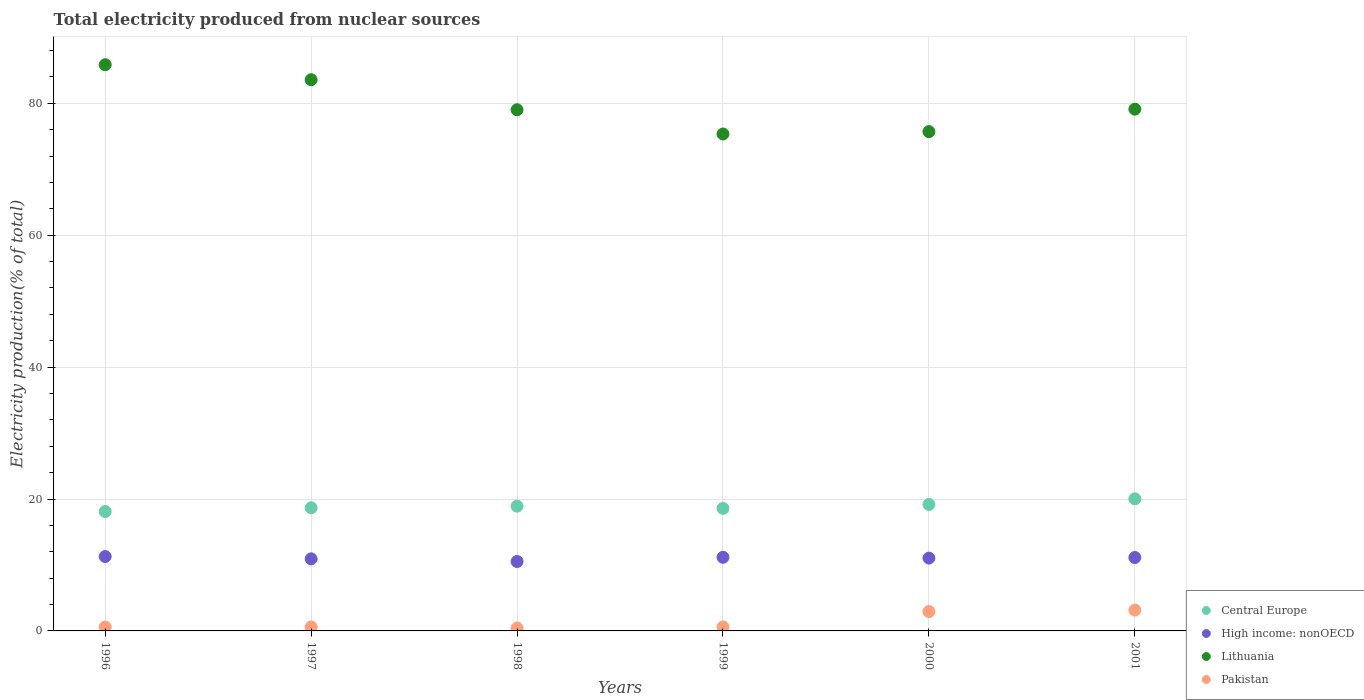How many different coloured dotlines are there?
Ensure brevity in your answer.  4. Is the number of dotlines equal to the number of legend labels?
Give a very brief answer. Yes. What is the total electricity produced in Lithuania in 1999?
Offer a very short reply. 75.35. Across all years, what is the maximum total electricity produced in Pakistan?
Ensure brevity in your answer.  3.16. Across all years, what is the minimum total electricity produced in Pakistan?
Your answer should be compact. 0.43. What is the total total electricity produced in Lithuania in the graph?
Your response must be concise. 478.59. What is the difference between the total electricity produced in Central Europe in 1996 and that in 2001?
Make the answer very short. -1.93. What is the difference between the total electricity produced in Lithuania in 1997 and the total electricity produced in Central Europe in 2001?
Ensure brevity in your answer.  63.54. What is the average total electricity produced in Central Europe per year?
Give a very brief answer. 18.91. In the year 1999, what is the difference between the total electricity produced in High income: nonOECD and total electricity produced in Pakistan?
Your answer should be compact. 10.56. In how many years, is the total electricity produced in Lithuania greater than 20 %?
Offer a terse response. 6. What is the ratio of the total electricity produced in Pakistan in 1996 to that in 2001?
Make the answer very short. 0.19. Is the total electricity produced in High income: nonOECD in 1998 less than that in 2000?
Provide a short and direct response. Yes. Is the difference between the total electricity produced in High income: nonOECD in 1996 and 1997 greater than the difference between the total electricity produced in Pakistan in 1996 and 1997?
Provide a short and direct response. Yes. What is the difference between the highest and the second highest total electricity produced in Central Europe?
Provide a succinct answer. 0.85. What is the difference between the highest and the lowest total electricity produced in Pakistan?
Provide a succinct answer. 2.73. Is it the case that in every year, the sum of the total electricity produced in Central Europe and total electricity produced in Pakistan  is greater than the total electricity produced in Lithuania?
Your response must be concise. No. Does the total electricity produced in Pakistan monotonically increase over the years?
Ensure brevity in your answer.  No. How many dotlines are there?
Ensure brevity in your answer.  4. How many years are there in the graph?
Your response must be concise. 6. Are the values on the major ticks of Y-axis written in scientific E-notation?
Your answer should be compact. No. Does the graph contain grids?
Make the answer very short. Yes. Where does the legend appear in the graph?
Your response must be concise. Bottom right. What is the title of the graph?
Make the answer very short. Total electricity produced from nuclear sources. Does "Hong Kong" appear as one of the legend labels in the graph?
Provide a succinct answer. No. What is the label or title of the X-axis?
Offer a terse response. Years. What is the Electricity production(% of total) of Central Europe in 1996?
Your answer should be very brief. 18.1. What is the Electricity production(% of total) in High income: nonOECD in 1996?
Your answer should be very brief. 11.28. What is the Electricity production(% of total) of Lithuania in 1996?
Ensure brevity in your answer.  85.84. What is the Electricity production(% of total) in Pakistan in 1996?
Give a very brief answer. 0.59. What is the Electricity production(% of total) of Central Europe in 1997?
Provide a succinct answer. 18.67. What is the Electricity production(% of total) in High income: nonOECD in 1997?
Provide a succinct answer. 10.93. What is the Electricity production(% of total) in Lithuania in 1997?
Keep it short and to the point. 83.57. What is the Electricity production(% of total) of Pakistan in 1997?
Your answer should be very brief. 0.6. What is the Electricity production(% of total) in Central Europe in 1998?
Provide a succinct answer. 18.91. What is the Electricity production(% of total) in High income: nonOECD in 1998?
Give a very brief answer. 10.52. What is the Electricity production(% of total) in Lithuania in 1998?
Offer a terse response. 79.02. What is the Electricity production(% of total) of Pakistan in 1998?
Your response must be concise. 0.43. What is the Electricity production(% of total) of Central Europe in 1999?
Your answer should be very brief. 18.58. What is the Electricity production(% of total) in High income: nonOECD in 1999?
Offer a terse response. 11.17. What is the Electricity production(% of total) of Lithuania in 1999?
Make the answer very short. 75.35. What is the Electricity production(% of total) in Pakistan in 1999?
Keep it short and to the point. 0.61. What is the Electricity production(% of total) of Central Europe in 2000?
Provide a short and direct response. 19.18. What is the Electricity production(% of total) in High income: nonOECD in 2000?
Your answer should be compact. 11.04. What is the Electricity production(% of total) in Lithuania in 2000?
Your answer should be very brief. 75.7. What is the Electricity production(% of total) of Pakistan in 2000?
Offer a very short reply. 2.93. What is the Electricity production(% of total) in Central Europe in 2001?
Ensure brevity in your answer.  20.03. What is the Electricity production(% of total) of High income: nonOECD in 2001?
Provide a succinct answer. 11.13. What is the Electricity production(% of total) of Lithuania in 2001?
Offer a very short reply. 79.11. What is the Electricity production(% of total) of Pakistan in 2001?
Provide a short and direct response. 3.16. Across all years, what is the maximum Electricity production(% of total) of Central Europe?
Your answer should be very brief. 20.03. Across all years, what is the maximum Electricity production(% of total) in High income: nonOECD?
Offer a terse response. 11.28. Across all years, what is the maximum Electricity production(% of total) in Lithuania?
Your answer should be very brief. 85.84. Across all years, what is the maximum Electricity production(% of total) in Pakistan?
Provide a succinct answer. 3.16. Across all years, what is the minimum Electricity production(% of total) of Central Europe?
Give a very brief answer. 18.1. Across all years, what is the minimum Electricity production(% of total) of High income: nonOECD?
Offer a very short reply. 10.52. Across all years, what is the minimum Electricity production(% of total) in Lithuania?
Provide a short and direct response. 75.35. Across all years, what is the minimum Electricity production(% of total) in Pakistan?
Provide a short and direct response. 0.43. What is the total Electricity production(% of total) in Central Europe in the graph?
Your answer should be compact. 113.47. What is the total Electricity production(% of total) of High income: nonOECD in the graph?
Offer a very short reply. 66.07. What is the total Electricity production(% of total) of Lithuania in the graph?
Your answer should be very brief. 478.59. What is the total Electricity production(% of total) in Pakistan in the graph?
Your answer should be compact. 8.32. What is the difference between the Electricity production(% of total) of Central Europe in 1996 and that in 1997?
Give a very brief answer. -0.57. What is the difference between the Electricity production(% of total) of High income: nonOECD in 1996 and that in 1997?
Your answer should be compact. 0.35. What is the difference between the Electricity production(% of total) in Lithuania in 1996 and that in 1997?
Your response must be concise. 2.27. What is the difference between the Electricity production(% of total) of Pakistan in 1996 and that in 1997?
Ensure brevity in your answer.  -0.02. What is the difference between the Electricity production(% of total) in Central Europe in 1996 and that in 1998?
Keep it short and to the point. -0.81. What is the difference between the Electricity production(% of total) of High income: nonOECD in 1996 and that in 1998?
Provide a short and direct response. 0.75. What is the difference between the Electricity production(% of total) in Lithuania in 1996 and that in 1998?
Give a very brief answer. 6.83. What is the difference between the Electricity production(% of total) in Pakistan in 1996 and that in 1998?
Provide a succinct answer. 0.15. What is the difference between the Electricity production(% of total) in Central Europe in 1996 and that in 1999?
Your answer should be compact. -0.48. What is the difference between the Electricity production(% of total) in High income: nonOECD in 1996 and that in 1999?
Ensure brevity in your answer.  0.11. What is the difference between the Electricity production(% of total) in Lithuania in 1996 and that in 1999?
Provide a succinct answer. 10.5. What is the difference between the Electricity production(% of total) in Pakistan in 1996 and that in 1999?
Ensure brevity in your answer.  -0.02. What is the difference between the Electricity production(% of total) in Central Europe in 1996 and that in 2000?
Keep it short and to the point. -1.08. What is the difference between the Electricity production(% of total) of High income: nonOECD in 1996 and that in 2000?
Provide a short and direct response. 0.24. What is the difference between the Electricity production(% of total) in Lithuania in 1996 and that in 2000?
Offer a terse response. 10.14. What is the difference between the Electricity production(% of total) in Pakistan in 1996 and that in 2000?
Provide a succinct answer. -2.35. What is the difference between the Electricity production(% of total) in Central Europe in 1996 and that in 2001?
Your response must be concise. -1.93. What is the difference between the Electricity production(% of total) of High income: nonOECD in 1996 and that in 2001?
Your answer should be very brief. 0.15. What is the difference between the Electricity production(% of total) in Lithuania in 1996 and that in 2001?
Give a very brief answer. 6.73. What is the difference between the Electricity production(% of total) of Pakistan in 1996 and that in 2001?
Provide a short and direct response. -2.58. What is the difference between the Electricity production(% of total) in Central Europe in 1997 and that in 1998?
Offer a terse response. -0.24. What is the difference between the Electricity production(% of total) in High income: nonOECD in 1997 and that in 1998?
Your answer should be very brief. 0.41. What is the difference between the Electricity production(% of total) of Lithuania in 1997 and that in 1998?
Make the answer very short. 4.55. What is the difference between the Electricity production(% of total) in Pakistan in 1997 and that in 1998?
Your response must be concise. 0.17. What is the difference between the Electricity production(% of total) of Central Europe in 1997 and that in 1999?
Give a very brief answer. 0.09. What is the difference between the Electricity production(% of total) in High income: nonOECD in 1997 and that in 1999?
Your answer should be very brief. -0.23. What is the difference between the Electricity production(% of total) in Lithuania in 1997 and that in 1999?
Offer a terse response. 8.22. What is the difference between the Electricity production(% of total) of Pakistan in 1997 and that in 1999?
Give a very brief answer. -0. What is the difference between the Electricity production(% of total) in Central Europe in 1997 and that in 2000?
Provide a succinct answer. -0.51. What is the difference between the Electricity production(% of total) of High income: nonOECD in 1997 and that in 2000?
Give a very brief answer. -0.11. What is the difference between the Electricity production(% of total) in Lithuania in 1997 and that in 2000?
Keep it short and to the point. 7.87. What is the difference between the Electricity production(% of total) in Pakistan in 1997 and that in 2000?
Your answer should be very brief. -2.33. What is the difference between the Electricity production(% of total) in Central Europe in 1997 and that in 2001?
Keep it short and to the point. -1.36. What is the difference between the Electricity production(% of total) of High income: nonOECD in 1997 and that in 2001?
Make the answer very short. -0.2. What is the difference between the Electricity production(% of total) of Lithuania in 1997 and that in 2001?
Ensure brevity in your answer.  4.46. What is the difference between the Electricity production(% of total) of Pakistan in 1997 and that in 2001?
Give a very brief answer. -2.56. What is the difference between the Electricity production(% of total) in Central Europe in 1998 and that in 1999?
Provide a short and direct response. 0.33. What is the difference between the Electricity production(% of total) in High income: nonOECD in 1998 and that in 1999?
Keep it short and to the point. -0.64. What is the difference between the Electricity production(% of total) in Lithuania in 1998 and that in 1999?
Make the answer very short. 3.67. What is the difference between the Electricity production(% of total) of Pakistan in 1998 and that in 1999?
Make the answer very short. -0.17. What is the difference between the Electricity production(% of total) of Central Europe in 1998 and that in 2000?
Make the answer very short. -0.27. What is the difference between the Electricity production(% of total) in High income: nonOECD in 1998 and that in 2000?
Keep it short and to the point. -0.52. What is the difference between the Electricity production(% of total) in Lithuania in 1998 and that in 2000?
Provide a short and direct response. 3.31. What is the difference between the Electricity production(% of total) in Pakistan in 1998 and that in 2000?
Your response must be concise. -2.5. What is the difference between the Electricity production(% of total) of Central Europe in 1998 and that in 2001?
Give a very brief answer. -1.11. What is the difference between the Electricity production(% of total) in High income: nonOECD in 1998 and that in 2001?
Provide a succinct answer. -0.6. What is the difference between the Electricity production(% of total) in Lithuania in 1998 and that in 2001?
Keep it short and to the point. -0.09. What is the difference between the Electricity production(% of total) of Pakistan in 1998 and that in 2001?
Your response must be concise. -2.73. What is the difference between the Electricity production(% of total) in Central Europe in 1999 and that in 2000?
Keep it short and to the point. -0.6. What is the difference between the Electricity production(% of total) in High income: nonOECD in 1999 and that in 2000?
Give a very brief answer. 0.12. What is the difference between the Electricity production(% of total) in Lithuania in 1999 and that in 2000?
Your answer should be compact. -0.36. What is the difference between the Electricity production(% of total) in Pakistan in 1999 and that in 2000?
Make the answer very short. -2.33. What is the difference between the Electricity production(% of total) of Central Europe in 1999 and that in 2001?
Keep it short and to the point. -1.45. What is the difference between the Electricity production(% of total) in High income: nonOECD in 1999 and that in 2001?
Ensure brevity in your answer.  0.04. What is the difference between the Electricity production(% of total) of Lithuania in 1999 and that in 2001?
Provide a succinct answer. -3.77. What is the difference between the Electricity production(% of total) in Pakistan in 1999 and that in 2001?
Provide a short and direct response. -2.56. What is the difference between the Electricity production(% of total) in Central Europe in 2000 and that in 2001?
Keep it short and to the point. -0.85. What is the difference between the Electricity production(% of total) in High income: nonOECD in 2000 and that in 2001?
Ensure brevity in your answer.  -0.09. What is the difference between the Electricity production(% of total) of Lithuania in 2000 and that in 2001?
Provide a short and direct response. -3.41. What is the difference between the Electricity production(% of total) of Pakistan in 2000 and that in 2001?
Offer a very short reply. -0.23. What is the difference between the Electricity production(% of total) of Central Europe in 1996 and the Electricity production(% of total) of High income: nonOECD in 1997?
Offer a terse response. 7.17. What is the difference between the Electricity production(% of total) of Central Europe in 1996 and the Electricity production(% of total) of Lithuania in 1997?
Give a very brief answer. -65.47. What is the difference between the Electricity production(% of total) of Central Europe in 1996 and the Electricity production(% of total) of Pakistan in 1997?
Keep it short and to the point. 17.5. What is the difference between the Electricity production(% of total) of High income: nonOECD in 1996 and the Electricity production(% of total) of Lithuania in 1997?
Offer a terse response. -72.29. What is the difference between the Electricity production(% of total) of High income: nonOECD in 1996 and the Electricity production(% of total) of Pakistan in 1997?
Provide a short and direct response. 10.67. What is the difference between the Electricity production(% of total) in Lithuania in 1996 and the Electricity production(% of total) in Pakistan in 1997?
Provide a succinct answer. 85.24. What is the difference between the Electricity production(% of total) in Central Europe in 1996 and the Electricity production(% of total) in High income: nonOECD in 1998?
Offer a very short reply. 7.58. What is the difference between the Electricity production(% of total) of Central Europe in 1996 and the Electricity production(% of total) of Lithuania in 1998?
Ensure brevity in your answer.  -60.92. What is the difference between the Electricity production(% of total) of Central Europe in 1996 and the Electricity production(% of total) of Pakistan in 1998?
Your answer should be very brief. 17.67. What is the difference between the Electricity production(% of total) of High income: nonOECD in 1996 and the Electricity production(% of total) of Lithuania in 1998?
Offer a terse response. -67.74. What is the difference between the Electricity production(% of total) in High income: nonOECD in 1996 and the Electricity production(% of total) in Pakistan in 1998?
Your answer should be compact. 10.84. What is the difference between the Electricity production(% of total) in Lithuania in 1996 and the Electricity production(% of total) in Pakistan in 1998?
Keep it short and to the point. 85.41. What is the difference between the Electricity production(% of total) in Central Europe in 1996 and the Electricity production(% of total) in High income: nonOECD in 1999?
Provide a succinct answer. 6.94. What is the difference between the Electricity production(% of total) in Central Europe in 1996 and the Electricity production(% of total) in Lithuania in 1999?
Your answer should be compact. -57.24. What is the difference between the Electricity production(% of total) of Central Europe in 1996 and the Electricity production(% of total) of Pakistan in 1999?
Your answer should be compact. 17.5. What is the difference between the Electricity production(% of total) in High income: nonOECD in 1996 and the Electricity production(% of total) in Lithuania in 1999?
Your answer should be compact. -64.07. What is the difference between the Electricity production(% of total) of High income: nonOECD in 1996 and the Electricity production(% of total) of Pakistan in 1999?
Offer a very short reply. 10.67. What is the difference between the Electricity production(% of total) in Lithuania in 1996 and the Electricity production(% of total) in Pakistan in 1999?
Your response must be concise. 85.24. What is the difference between the Electricity production(% of total) of Central Europe in 1996 and the Electricity production(% of total) of High income: nonOECD in 2000?
Offer a very short reply. 7.06. What is the difference between the Electricity production(% of total) of Central Europe in 1996 and the Electricity production(% of total) of Lithuania in 2000?
Your answer should be very brief. -57.6. What is the difference between the Electricity production(% of total) in Central Europe in 1996 and the Electricity production(% of total) in Pakistan in 2000?
Provide a short and direct response. 15.17. What is the difference between the Electricity production(% of total) in High income: nonOECD in 1996 and the Electricity production(% of total) in Lithuania in 2000?
Keep it short and to the point. -64.43. What is the difference between the Electricity production(% of total) in High income: nonOECD in 1996 and the Electricity production(% of total) in Pakistan in 2000?
Provide a succinct answer. 8.35. What is the difference between the Electricity production(% of total) in Lithuania in 1996 and the Electricity production(% of total) in Pakistan in 2000?
Your answer should be very brief. 82.91. What is the difference between the Electricity production(% of total) of Central Europe in 1996 and the Electricity production(% of total) of High income: nonOECD in 2001?
Your answer should be compact. 6.97. What is the difference between the Electricity production(% of total) of Central Europe in 1996 and the Electricity production(% of total) of Lithuania in 2001?
Keep it short and to the point. -61.01. What is the difference between the Electricity production(% of total) in Central Europe in 1996 and the Electricity production(% of total) in Pakistan in 2001?
Provide a short and direct response. 14.94. What is the difference between the Electricity production(% of total) of High income: nonOECD in 1996 and the Electricity production(% of total) of Lithuania in 2001?
Offer a very short reply. -67.83. What is the difference between the Electricity production(% of total) of High income: nonOECD in 1996 and the Electricity production(% of total) of Pakistan in 2001?
Give a very brief answer. 8.11. What is the difference between the Electricity production(% of total) of Lithuania in 1996 and the Electricity production(% of total) of Pakistan in 2001?
Ensure brevity in your answer.  82.68. What is the difference between the Electricity production(% of total) in Central Europe in 1997 and the Electricity production(% of total) in High income: nonOECD in 1998?
Your response must be concise. 8.15. What is the difference between the Electricity production(% of total) in Central Europe in 1997 and the Electricity production(% of total) in Lithuania in 1998?
Your answer should be compact. -60.35. What is the difference between the Electricity production(% of total) of Central Europe in 1997 and the Electricity production(% of total) of Pakistan in 1998?
Your answer should be very brief. 18.24. What is the difference between the Electricity production(% of total) in High income: nonOECD in 1997 and the Electricity production(% of total) in Lithuania in 1998?
Give a very brief answer. -68.09. What is the difference between the Electricity production(% of total) in High income: nonOECD in 1997 and the Electricity production(% of total) in Pakistan in 1998?
Provide a succinct answer. 10.5. What is the difference between the Electricity production(% of total) in Lithuania in 1997 and the Electricity production(% of total) in Pakistan in 1998?
Your response must be concise. 83.14. What is the difference between the Electricity production(% of total) of Central Europe in 1997 and the Electricity production(% of total) of High income: nonOECD in 1999?
Provide a succinct answer. 7.5. What is the difference between the Electricity production(% of total) in Central Europe in 1997 and the Electricity production(% of total) in Lithuania in 1999?
Offer a terse response. -56.68. What is the difference between the Electricity production(% of total) of Central Europe in 1997 and the Electricity production(% of total) of Pakistan in 1999?
Your response must be concise. 18.06. What is the difference between the Electricity production(% of total) of High income: nonOECD in 1997 and the Electricity production(% of total) of Lithuania in 1999?
Your response must be concise. -64.41. What is the difference between the Electricity production(% of total) of High income: nonOECD in 1997 and the Electricity production(% of total) of Pakistan in 1999?
Your answer should be very brief. 10.33. What is the difference between the Electricity production(% of total) in Lithuania in 1997 and the Electricity production(% of total) in Pakistan in 1999?
Your answer should be compact. 82.96. What is the difference between the Electricity production(% of total) of Central Europe in 1997 and the Electricity production(% of total) of High income: nonOECD in 2000?
Your answer should be very brief. 7.63. What is the difference between the Electricity production(% of total) in Central Europe in 1997 and the Electricity production(% of total) in Lithuania in 2000?
Your answer should be compact. -57.03. What is the difference between the Electricity production(% of total) in Central Europe in 1997 and the Electricity production(% of total) in Pakistan in 2000?
Give a very brief answer. 15.74. What is the difference between the Electricity production(% of total) in High income: nonOECD in 1997 and the Electricity production(% of total) in Lithuania in 2000?
Your answer should be very brief. -64.77. What is the difference between the Electricity production(% of total) in High income: nonOECD in 1997 and the Electricity production(% of total) in Pakistan in 2000?
Your response must be concise. 8. What is the difference between the Electricity production(% of total) in Lithuania in 1997 and the Electricity production(% of total) in Pakistan in 2000?
Offer a terse response. 80.64. What is the difference between the Electricity production(% of total) in Central Europe in 1997 and the Electricity production(% of total) in High income: nonOECD in 2001?
Your response must be concise. 7.54. What is the difference between the Electricity production(% of total) in Central Europe in 1997 and the Electricity production(% of total) in Lithuania in 2001?
Give a very brief answer. -60.44. What is the difference between the Electricity production(% of total) of Central Europe in 1997 and the Electricity production(% of total) of Pakistan in 2001?
Your answer should be very brief. 15.51. What is the difference between the Electricity production(% of total) of High income: nonOECD in 1997 and the Electricity production(% of total) of Lithuania in 2001?
Make the answer very short. -68.18. What is the difference between the Electricity production(% of total) in High income: nonOECD in 1997 and the Electricity production(% of total) in Pakistan in 2001?
Your answer should be compact. 7.77. What is the difference between the Electricity production(% of total) of Lithuania in 1997 and the Electricity production(% of total) of Pakistan in 2001?
Your answer should be very brief. 80.41. What is the difference between the Electricity production(% of total) of Central Europe in 1998 and the Electricity production(% of total) of High income: nonOECD in 1999?
Your response must be concise. 7.75. What is the difference between the Electricity production(% of total) in Central Europe in 1998 and the Electricity production(% of total) in Lithuania in 1999?
Your response must be concise. -56.43. What is the difference between the Electricity production(% of total) in Central Europe in 1998 and the Electricity production(% of total) in Pakistan in 1999?
Your answer should be compact. 18.31. What is the difference between the Electricity production(% of total) of High income: nonOECD in 1998 and the Electricity production(% of total) of Lithuania in 1999?
Offer a terse response. -64.82. What is the difference between the Electricity production(% of total) in High income: nonOECD in 1998 and the Electricity production(% of total) in Pakistan in 1999?
Give a very brief answer. 9.92. What is the difference between the Electricity production(% of total) of Lithuania in 1998 and the Electricity production(% of total) of Pakistan in 1999?
Keep it short and to the point. 78.41. What is the difference between the Electricity production(% of total) in Central Europe in 1998 and the Electricity production(% of total) in High income: nonOECD in 2000?
Your answer should be compact. 7.87. What is the difference between the Electricity production(% of total) of Central Europe in 1998 and the Electricity production(% of total) of Lithuania in 2000?
Your response must be concise. -56.79. What is the difference between the Electricity production(% of total) in Central Europe in 1998 and the Electricity production(% of total) in Pakistan in 2000?
Provide a succinct answer. 15.98. What is the difference between the Electricity production(% of total) of High income: nonOECD in 1998 and the Electricity production(% of total) of Lithuania in 2000?
Offer a very short reply. -65.18. What is the difference between the Electricity production(% of total) in High income: nonOECD in 1998 and the Electricity production(% of total) in Pakistan in 2000?
Offer a terse response. 7.59. What is the difference between the Electricity production(% of total) in Lithuania in 1998 and the Electricity production(% of total) in Pakistan in 2000?
Your answer should be compact. 76.09. What is the difference between the Electricity production(% of total) in Central Europe in 1998 and the Electricity production(% of total) in High income: nonOECD in 2001?
Give a very brief answer. 7.79. What is the difference between the Electricity production(% of total) in Central Europe in 1998 and the Electricity production(% of total) in Lithuania in 2001?
Your answer should be compact. -60.2. What is the difference between the Electricity production(% of total) of Central Europe in 1998 and the Electricity production(% of total) of Pakistan in 2001?
Your answer should be compact. 15.75. What is the difference between the Electricity production(% of total) in High income: nonOECD in 1998 and the Electricity production(% of total) in Lithuania in 2001?
Offer a terse response. -68.59. What is the difference between the Electricity production(% of total) of High income: nonOECD in 1998 and the Electricity production(% of total) of Pakistan in 2001?
Provide a succinct answer. 7.36. What is the difference between the Electricity production(% of total) of Lithuania in 1998 and the Electricity production(% of total) of Pakistan in 2001?
Your answer should be compact. 75.86. What is the difference between the Electricity production(% of total) of Central Europe in 1999 and the Electricity production(% of total) of High income: nonOECD in 2000?
Make the answer very short. 7.54. What is the difference between the Electricity production(% of total) in Central Europe in 1999 and the Electricity production(% of total) in Lithuania in 2000?
Offer a terse response. -57.12. What is the difference between the Electricity production(% of total) of Central Europe in 1999 and the Electricity production(% of total) of Pakistan in 2000?
Ensure brevity in your answer.  15.65. What is the difference between the Electricity production(% of total) in High income: nonOECD in 1999 and the Electricity production(% of total) in Lithuania in 2000?
Ensure brevity in your answer.  -64.54. What is the difference between the Electricity production(% of total) in High income: nonOECD in 1999 and the Electricity production(% of total) in Pakistan in 2000?
Make the answer very short. 8.23. What is the difference between the Electricity production(% of total) of Lithuania in 1999 and the Electricity production(% of total) of Pakistan in 2000?
Keep it short and to the point. 72.41. What is the difference between the Electricity production(% of total) in Central Europe in 1999 and the Electricity production(% of total) in High income: nonOECD in 2001?
Give a very brief answer. 7.45. What is the difference between the Electricity production(% of total) of Central Europe in 1999 and the Electricity production(% of total) of Lithuania in 2001?
Offer a terse response. -60.53. What is the difference between the Electricity production(% of total) in Central Europe in 1999 and the Electricity production(% of total) in Pakistan in 2001?
Your answer should be compact. 15.42. What is the difference between the Electricity production(% of total) of High income: nonOECD in 1999 and the Electricity production(% of total) of Lithuania in 2001?
Offer a very short reply. -67.95. What is the difference between the Electricity production(% of total) of High income: nonOECD in 1999 and the Electricity production(% of total) of Pakistan in 2001?
Your answer should be compact. 8. What is the difference between the Electricity production(% of total) of Lithuania in 1999 and the Electricity production(% of total) of Pakistan in 2001?
Your answer should be compact. 72.18. What is the difference between the Electricity production(% of total) of Central Europe in 2000 and the Electricity production(% of total) of High income: nonOECD in 2001?
Provide a short and direct response. 8.05. What is the difference between the Electricity production(% of total) of Central Europe in 2000 and the Electricity production(% of total) of Lithuania in 2001?
Make the answer very short. -59.93. What is the difference between the Electricity production(% of total) in Central Europe in 2000 and the Electricity production(% of total) in Pakistan in 2001?
Give a very brief answer. 16.02. What is the difference between the Electricity production(% of total) of High income: nonOECD in 2000 and the Electricity production(% of total) of Lithuania in 2001?
Keep it short and to the point. -68.07. What is the difference between the Electricity production(% of total) in High income: nonOECD in 2000 and the Electricity production(% of total) in Pakistan in 2001?
Offer a very short reply. 7.88. What is the difference between the Electricity production(% of total) of Lithuania in 2000 and the Electricity production(% of total) of Pakistan in 2001?
Give a very brief answer. 72.54. What is the average Electricity production(% of total) in Central Europe per year?
Give a very brief answer. 18.91. What is the average Electricity production(% of total) of High income: nonOECD per year?
Give a very brief answer. 11.01. What is the average Electricity production(% of total) in Lithuania per year?
Provide a succinct answer. 79.77. What is the average Electricity production(% of total) in Pakistan per year?
Offer a very short reply. 1.39. In the year 1996, what is the difference between the Electricity production(% of total) of Central Europe and Electricity production(% of total) of High income: nonOECD?
Offer a very short reply. 6.82. In the year 1996, what is the difference between the Electricity production(% of total) of Central Europe and Electricity production(% of total) of Lithuania?
Give a very brief answer. -67.74. In the year 1996, what is the difference between the Electricity production(% of total) in Central Europe and Electricity production(% of total) in Pakistan?
Your answer should be very brief. 17.52. In the year 1996, what is the difference between the Electricity production(% of total) of High income: nonOECD and Electricity production(% of total) of Lithuania?
Your response must be concise. -74.57. In the year 1996, what is the difference between the Electricity production(% of total) in High income: nonOECD and Electricity production(% of total) in Pakistan?
Your answer should be compact. 10.69. In the year 1996, what is the difference between the Electricity production(% of total) in Lithuania and Electricity production(% of total) in Pakistan?
Give a very brief answer. 85.26. In the year 1997, what is the difference between the Electricity production(% of total) of Central Europe and Electricity production(% of total) of High income: nonOECD?
Provide a short and direct response. 7.74. In the year 1997, what is the difference between the Electricity production(% of total) in Central Europe and Electricity production(% of total) in Lithuania?
Offer a very short reply. -64.9. In the year 1997, what is the difference between the Electricity production(% of total) in Central Europe and Electricity production(% of total) in Pakistan?
Make the answer very short. 18.07. In the year 1997, what is the difference between the Electricity production(% of total) in High income: nonOECD and Electricity production(% of total) in Lithuania?
Ensure brevity in your answer.  -72.64. In the year 1997, what is the difference between the Electricity production(% of total) in High income: nonOECD and Electricity production(% of total) in Pakistan?
Offer a terse response. 10.33. In the year 1997, what is the difference between the Electricity production(% of total) of Lithuania and Electricity production(% of total) of Pakistan?
Make the answer very short. 82.97. In the year 1998, what is the difference between the Electricity production(% of total) in Central Europe and Electricity production(% of total) in High income: nonOECD?
Your answer should be compact. 8.39. In the year 1998, what is the difference between the Electricity production(% of total) of Central Europe and Electricity production(% of total) of Lithuania?
Keep it short and to the point. -60.1. In the year 1998, what is the difference between the Electricity production(% of total) of Central Europe and Electricity production(% of total) of Pakistan?
Give a very brief answer. 18.48. In the year 1998, what is the difference between the Electricity production(% of total) of High income: nonOECD and Electricity production(% of total) of Lithuania?
Offer a very short reply. -68.49. In the year 1998, what is the difference between the Electricity production(% of total) of High income: nonOECD and Electricity production(% of total) of Pakistan?
Provide a succinct answer. 10.09. In the year 1998, what is the difference between the Electricity production(% of total) in Lithuania and Electricity production(% of total) in Pakistan?
Provide a succinct answer. 78.58. In the year 1999, what is the difference between the Electricity production(% of total) of Central Europe and Electricity production(% of total) of High income: nonOECD?
Your answer should be compact. 7.41. In the year 1999, what is the difference between the Electricity production(% of total) of Central Europe and Electricity production(% of total) of Lithuania?
Ensure brevity in your answer.  -56.77. In the year 1999, what is the difference between the Electricity production(% of total) in Central Europe and Electricity production(% of total) in Pakistan?
Offer a terse response. 17.97. In the year 1999, what is the difference between the Electricity production(% of total) of High income: nonOECD and Electricity production(% of total) of Lithuania?
Offer a very short reply. -64.18. In the year 1999, what is the difference between the Electricity production(% of total) of High income: nonOECD and Electricity production(% of total) of Pakistan?
Keep it short and to the point. 10.56. In the year 1999, what is the difference between the Electricity production(% of total) of Lithuania and Electricity production(% of total) of Pakistan?
Your answer should be compact. 74.74. In the year 2000, what is the difference between the Electricity production(% of total) in Central Europe and Electricity production(% of total) in High income: nonOECD?
Your answer should be compact. 8.14. In the year 2000, what is the difference between the Electricity production(% of total) of Central Europe and Electricity production(% of total) of Lithuania?
Provide a short and direct response. -56.52. In the year 2000, what is the difference between the Electricity production(% of total) in Central Europe and Electricity production(% of total) in Pakistan?
Offer a terse response. 16.25. In the year 2000, what is the difference between the Electricity production(% of total) in High income: nonOECD and Electricity production(% of total) in Lithuania?
Provide a short and direct response. -64.66. In the year 2000, what is the difference between the Electricity production(% of total) of High income: nonOECD and Electricity production(% of total) of Pakistan?
Your answer should be very brief. 8.11. In the year 2000, what is the difference between the Electricity production(% of total) in Lithuania and Electricity production(% of total) in Pakistan?
Offer a very short reply. 72.77. In the year 2001, what is the difference between the Electricity production(% of total) of Central Europe and Electricity production(% of total) of High income: nonOECD?
Give a very brief answer. 8.9. In the year 2001, what is the difference between the Electricity production(% of total) of Central Europe and Electricity production(% of total) of Lithuania?
Your answer should be compact. -59.08. In the year 2001, what is the difference between the Electricity production(% of total) in Central Europe and Electricity production(% of total) in Pakistan?
Give a very brief answer. 16.87. In the year 2001, what is the difference between the Electricity production(% of total) of High income: nonOECD and Electricity production(% of total) of Lithuania?
Keep it short and to the point. -67.98. In the year 2001, what is the difference between the Electricity production(% of total) of High income: nonOECD and Electricity production(% of total) of Pakistan?
Make the answer very short. 7.97. In the year 2001, what is the difference between the Electricity production(% of total) of Lithuania and Electricity production(% of total) of Pakistan?
Offer a terse response. 75.95. What is the ratio of the Electricity production(% of total) of Central Europe in 1996 to that in 1997?
Provide a succinct answer. 0.97. What is the ratio of the Electricity production(% of total) in High income: nonOECD in 1996 to that in 1997?
Your answer should be compact. 1.03. What is the ratio of the Electricity production(% of total) of Lithuania in 1996 to that in 1997?
Make the answer very short. 1.03. What is the ratio of the Electricity production(% of total) of Central Europe in 1996 to that in 1998?
Keep it short and to the point. 0.96. What is the ratio of the Electricity production(% of total) of High income: nonOECD in 1996 to that in 1998?
Your response must be concise. 1.07. What is the ratio of the Electricity production(% of total) in Lithuania in 1996 to that in 1998?
Ensure brevity in your answer.  1.09. What is the ratio of the Electricity production(% of total) of Pakistan in 1996 to that in 1998?
Offer a terse response. 1.35. What is the ratio of the Electricity production(% of total) of Central Europe in 1996 to that in 1999?
Your answer should be very brief. 0.97. What is the ratio of the Electricity production(% of total) in Lithuania in 1996 to that in 1999?
Provide a short and direct response. 1.14. What is the ratio of the Electricity production(% of total) of Pakistan in 1996 to that in 1999?
Your answer should be compact. 0.96. What is the ratio of the Electricity production(% of total) of Central Europe in 1996 to that in 2000?
Your answer should be very brief. 0.94. What is the ratio of the Electricity production(% of total) in High income: nonOECD in 1996 to that in 2000?
Your response must be concise. 1.02. What is the ratio of the Electricity production(% of total) of Lithuania in 1996 to that in 2000?
Your answer should be very brief. 1.13. What is the ratio of the Electricity production(% of total) of Pakistan in 1996 to that in 2000?
Make the answer very short. 0.2. What is the ratio of the Electricity production(% of total) in Central Europe in 1996 to that in 2001?
Make the answer very short. 0.9. What is the ratio of the Electricity production(% of total) in High income: nonOECD in 1996 to that in 2001?
Provide a short and direct response. 1.01. What is the ratio of the Electricity production(% of total) in Lithuania in 1996 to that in 2001?
Give a very brief answer. 1.09. What is the ratio of the Electricity production(% of total) in Pakistan in 1996 to that in 2001?
Ensure brevity in your answer.  0.18. What is the ratio of the Electricity production(% of total) of Central Europe in 1997 to that in 1998?
Your answer should be very brief. 0.99. What is the ratio of the Electricity production(% of total) of High income: nonOECD in 1997 to that in 1998?
Make the answer very short. 1.04. What is the ratio of the Electricity production(% of total) in Lithuania in 1997 to that in 1998?
Your answer should be very brief. 1.06. What is the ratio of the Electricity production(% of total) of Pakistan in 1997 to that in 1998?
Ensure brevity in your answer.  1.39. What is the ratio of the Electricity production(% of total) in Central Europe in 1997 to that in 1999?
Your answer should be compact. 1. What is the ratio of the Electricity production(% of total) in High income: nonOECD in 1997 to that in 1999?
Keep it short and to the point. 0.98. What is the ratio of the Electricity production(% of total) of Lithuania in 1997 to that in 1999?
Provide a short and direct response. 1.11. What is the ratio of the Electricity production(% of total) of Central Europe in 1997 to that in 2000?
Your answer should be very brief. 0.97. What is the ratio of the Electricity production(% of total) of High income: nonOECD in 1997 to that in 2000?
Provide a short and direct response. 0.99. What is the ratio of the Electricity production(% of total) of Lithuania in 1997 to that in 2000?
Keep it short and to the point. 1.1. What is the ratio of the Electricity production(% of total) of Pakistan in 1997 to that in 2000?
Give a very brief answer. 0.21. What is the ratio of the Electricity production(% of total) of Central Europe in 1997 to that in 2001?
Ensure brevity in your answer.  0.93. What is the ratio of the Electricity production(% of total) of High income: nonOECD in 1997 to that in 2001?
Your response must be concise. 0.98. What is the ratio of the Electricity production(% of total) in Lithuania in 1997 to that in 2001?
Provide a short and direct response. 1.06. What is the ratio of the Electricity production(% of total) in Pakistan in 1997 to that in 2001?
Your answer should be very brief. 0.19. What is the ratio of the Electricity production(% of total) in Central Europe in 1998 to that in 1999?
Ensure brevity in your answer.  1.02. What is the ratio of the Electricity production(% of total) in High income: nonOECD in 1998 to that in 1999?
Your answer should be very brief. 0.94. What is the ratio of the Electricity production(% of total) of Lithuania in 1998 to that in 1999?
Provide a short and direct response. 1.05. What is the ratio of the Electricity production(% of total) in Pakistan in 1998 to that in 1999?
Give a very brief answer. 0.72. What is the ratio of the Electricity production(% of total) of Central Europe in 1998 to that in 2000?
Offer a terse response. 0.99. What is the ratio of the Electricity production(% of total) in High income: nonOECD in 1998 to that in 2000?
Offer a very short reply. 0.95. What is the ratio of the Electricity production(% of total) in Lithuania in 1998 to that in 2000?
Make the answer very short. 1.04. What is the ratio of the Electricity production(% of total) of Pakistan in 1998 to that in 2000?
Your answer should be compact. 0.15. What is the ratio of the Electricity production(% of total) of High income: nonOECD in 1998 to that in 2001?
Provide a succinct answer. 0.95. What is the ratio of the Electricity production(% of total) in Lithuania in 1998 to that in 2001?
Your answer should be very brief. 1. What is the ratio of the Electricity production(% of total) of Pakistan in 1998 to that in 2001?
Your answer should be very brief. 0.14. What is the ratio of the Electricity production(% of total) in Central Europe in 1999 to that in 2000?
Offer a terse response. 0.97. What is the ratio of the Electricity production(% of total) of High income: nonOECD in 1999 to that in 2000?
Offer a very short reply. 1.01. What is the ratio of the Electricity production(% of total) in Lithuania in 1999 to that in 2000?
Make the answer very short. 1. What is the ratio of the Electricity production(% of total) of Pakistan in 1999 to that in 2000?
Offer a terse response. 0.21. What is the ratio of the Electricity production(% of total) in Central Europe in 1999 to that in 2001?
Provide a succinct answer. 0.93. What is the ratio of the Electricity production(% of total) in Lithuania in 1999 to that in 2001?
Your answer should be very brief. 0.95. What is the ratio of the Electricity production(% of total) of Pakistan in 1999 to that in 2001?
Ensure brevity in your answer.  0.19. What is the ratio of the Electricity production(% of total) in Central Europe in 2000 to that in 2001?
Keep it short and to the point. 0.96. What is the ratio of the Electricity production(% of total) of High income: nonOECD in 2000 to that in 2001?
Your answer should be very brief. 0.99. What is the ratio of the Electricity production(% of total) of Lithuania in 2000 to that in 2001?
Give a very brief answer. 0.96. What is the ratio of the Electricity production(% of total) of Pakistan in 2000 to that in 2001?
Make the answer very short. 0.93. What is the difference between the highest and the second highest Electricity production(% of total) in Central Europe?
Provide a succinct answer. 0.85. What is the difference between the highest and the second highest Electricity production(% of total) of High income: nonOECD?
Keep it short and to the point. 0.11. What is the difference between the highest and the second highest Electricity production(% of total) in Lithuania?
Give a very brief answer. 2.27. What is the difference between the highest and the second highest Electricity production(% of total) of Pakistan?
Offer a very short reply. 0.23. What is the difference between the highest and the lowest Electricity production(% of total) in Central Europe?
Make the answer very short. 1.93. What is the difference between the highest and the lowest Electricity production(% of total) in High income: nonOECD?
Provide a succinct answer. 0.75. What is the difference between the highest and the lowest Electricity production(% of total) of Lithuania?
Make the answer very short. 10.5. What is the difference between the highest and the lowest Electricity production(% of total) in Pakistan?
Provide a succinct answer. 2.73. 